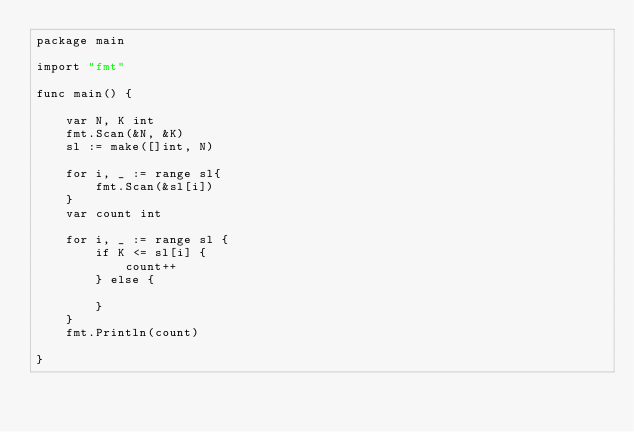Convert code to text. <code><loc_0><loc_0><loc_500><loc_500><_Go_>package main

import "fmt"

func main() {

	var N, K int
	fmt.Scan(&N, &K)
	sl := make([]int, N)

	for i, _ := range sl{
		fmt.Scan(&sl[i])
	}
	var count int

	for i, _ := range sl {
		if K <= sl[i] {
			count++
		} else {

		}
	}
	fmt.Println(count)

}
</code> 